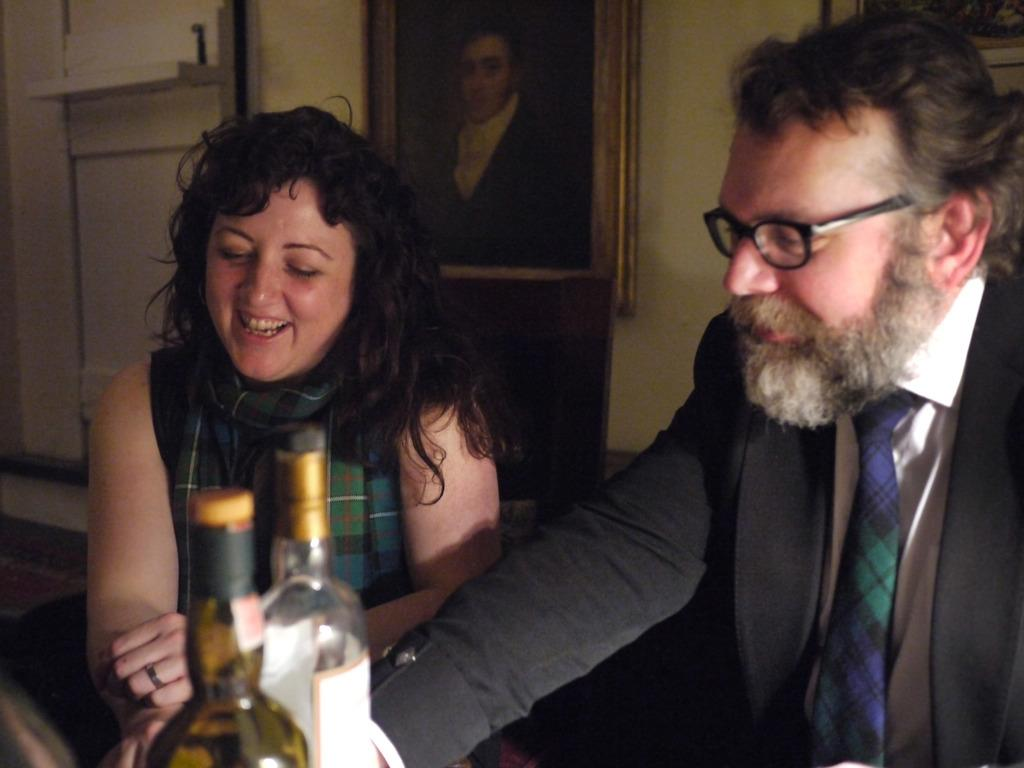What type of structure can be seen in the image? There is a wall in the image. What is hanging on the wall? There is a photo frame in the image. What are the two people in the image doing? The two people are sitting on chairs in the image. What objects can be seen on the table or nearby? There are two bottles in the image. What type of soup is being served in the image? There is no soup present in the image. How many books can be seen on the table in the image? There are no books visible in the image. 